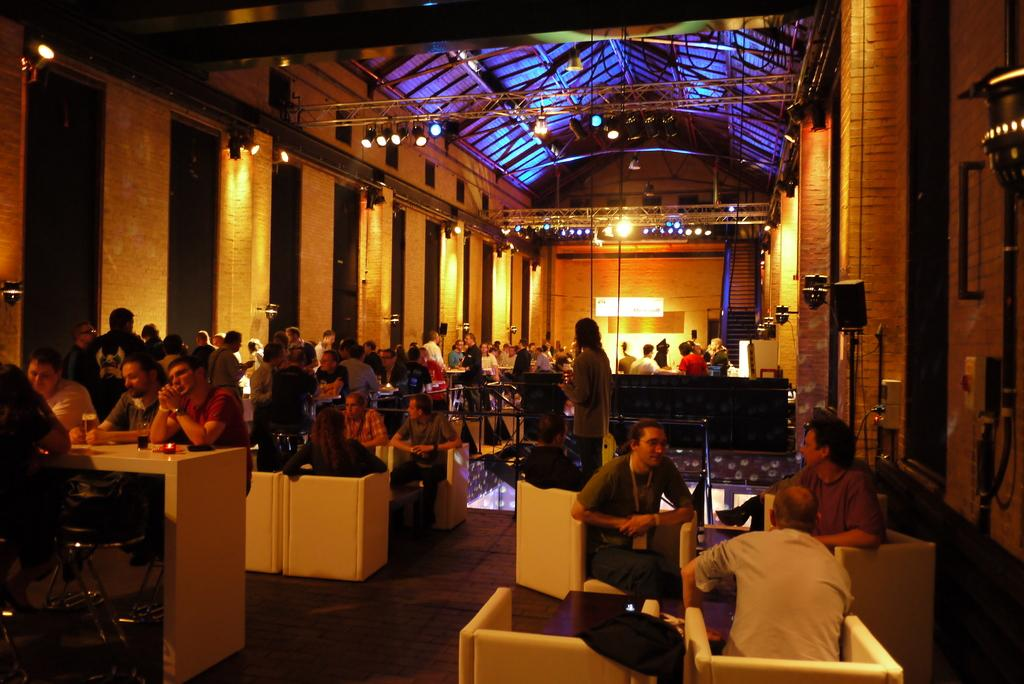Who is present in the image? There are people in the image. Where are the people located? The people are in a restaurant. How are the people arranged in the image? The people are sitting in groups. Can you describe the seating arrangement in the image? There are different tables in the image. What type of paint is being used to decorate the cabbage on the table? There is no cabbage or paint present in the image. The image features people sitting in a restaurant at different tables. 